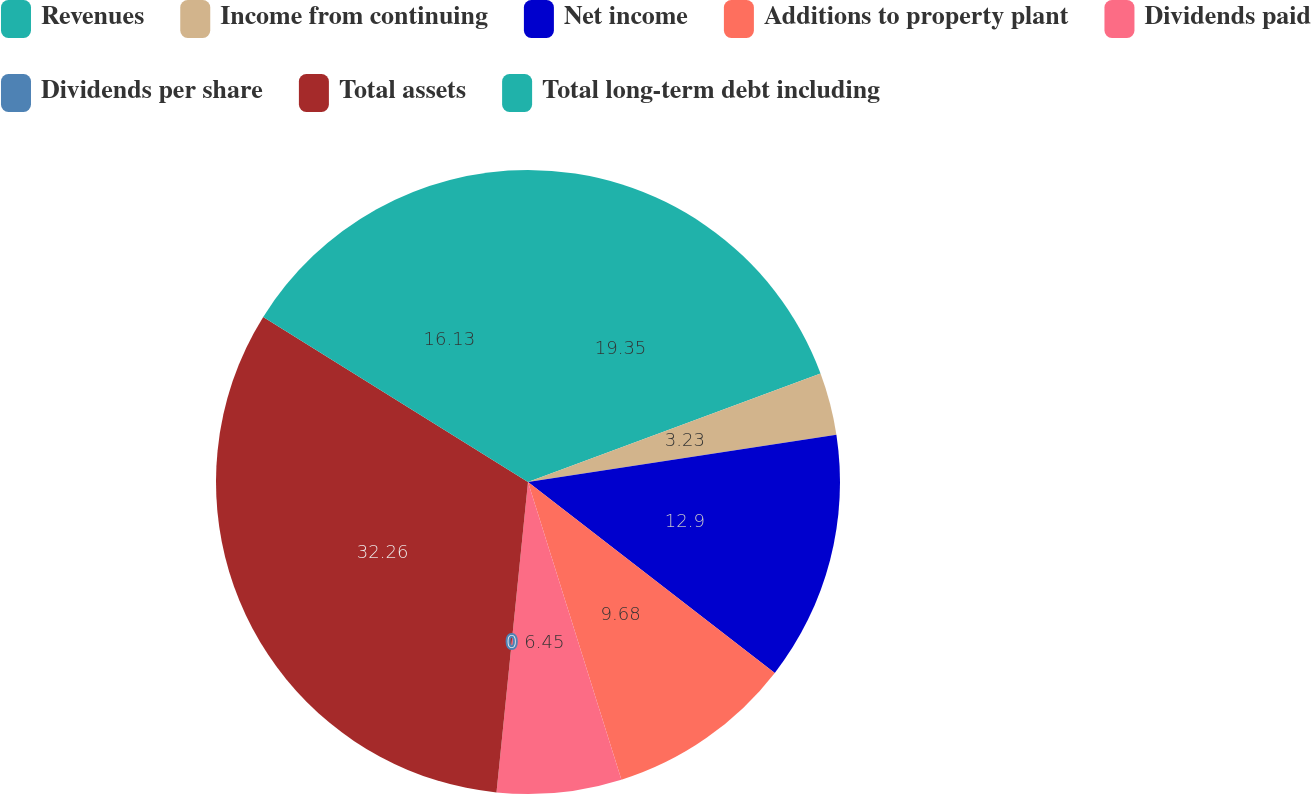Convert chart to OTSL. <chart><loc_0><loc_0><loc_500><loc_500><pie_chart><fcel>Revenues<fcel>Income from continuing<fcel>Net income<fcel>Additions to property plant<fcel>Dividends paid<fcel>Dividends per share<fcel>Total assets<fcel>Total long-term debt including<nl><fcel>19.35%<fcel>3.23%<fcel>12.9%<fcel>9.68%<fcel>6.45%<fcel>0.0%<fcel>32.26%<fcel>16.13%<nl></chart> 